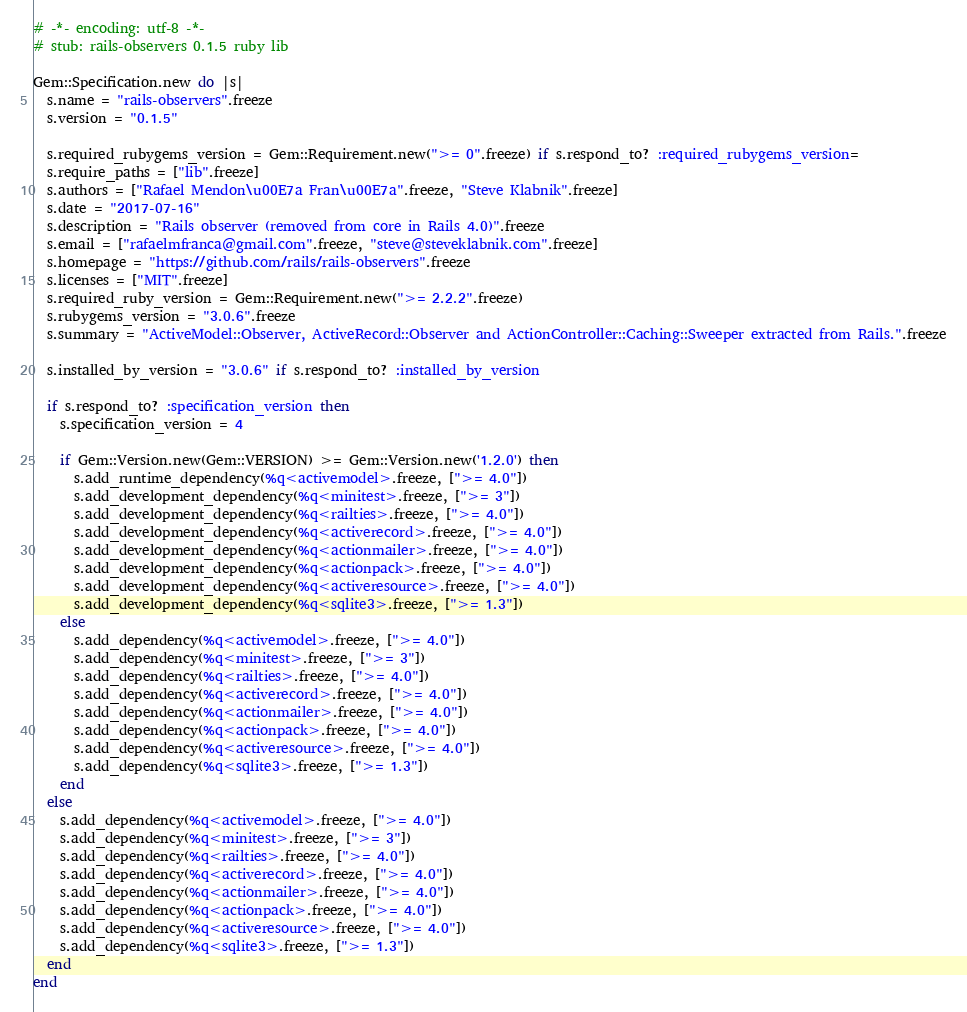<code> <loc_0><loc_0><loc_500><loc_500><_Ruby_># -*- encoding: utf-8 -*-
# stub: rails-observers 0.1.5 ruby lib

Gem::Specification.new do |s|
  s.name = "rails-observers".freeze
  s.version = "0.1.5"

  s.required_rubygems_version = Gem::Requirement.new(">= 0".freeze) if s.respond_to? :required_rubygems_version=
  s.require_paths = ["lib".freeze]
  s.authors = ["Rafael Mendon\u00E7a Fran\u00E7a".freeze, "Steve Klabnik".freeze]
  s.date = "2017-07-16"
  s.description = "Rails observer (removed from core in Rails 4.0)".freeze
  s.email = ["rafaelmfranca@gmail.com".freeze, "steve@steveklabnik.com".freeze]
  s.homepage = "https://github.com/rails/rails-observers".freeze
  s.licenses = ["MIT".freeze]
  s.required_ruby_version = Gem::Requirement.new(">= 2.2.2".freeze)
  s.rubygems_version = "3.0.6".freeze
  s.summary = "ActiveModel::Observer, ActiveRecord::Observer and ActionController::Caching::Sweeper extracted from Rails.".freeze

  s.installed_by_version = "3.0.6" if s.respond_to? :installed_by_version

  if s.respond_to? :specification_version then
    s.specification_version = 4

    if Gem::Version.new(Gem::VERSION) >= Gem::Version.new('1.2.0') then
      s.add_runtime_dependency(%q<activemodel>.freeze, [">= 4.0"])
      s.add_development_dependency(%q<minitest>.freeze, [">= 3"])
      s.add_development_dependency(%q<railties>.freeze, [">= 4.0"])
      s.add_development_dependency(%q<activerecord>.freeze, [">= 4.0"])
      s.add_development_dependency(%q<actionmailer>.freeze, [">= 4.0"])
      s.add_development_dependency(%q<actionpack>.freeze, [">= 4.0"])
      s.add_development_dependency(%q<activeresource>.freeze, [">= 4.0"])
      s.add_development_dependency(%q<sqlite3>.freeze, [">= 1.3"])
    else
      s.add_dependency(%q<activemodel>.freeze, [">= 4.0"])
      s.add_dependency(%q<minitest>.freeze, [">= 3"])
      s.add_dependency(%q<railties>.freeze, [">= 4.0"])
      s.add_dependency(%q<activerecord>.freeze, [">= 4.0"])
      s.add_dependency(%q<actionmailer>.freeze, [">= 4.0"])
      s.add_dependency(%q<actionpack>.freeze, [">= 4.0"])
      s.add_dependency(%q<activeresource>.freeze, [">= 4.0"])
      s.add_dependency(%q<sqlite3>.freeze, [">= 1.3"])
    end
  else
    s.add_dependency(%q<activemodel>.freeze, [">= 4.0"])
    s.add_dependency(%q<minitest>.freeze, [">= 3"])
    s.add_dependency(%q<railties>.freeze, [">= 4.0"])
    s.add_dependency(%q<activerecord>.freeze, [">= 4.0"])
    s.add_dependency(%q<actionmailer>.freeze, [">= 4.0"])
    s.add_dependency(%q<actionpack>.freeze, [">= 4.0"])
    s.add_dependency(%q<activeresource>.freeze, [">= 4.0"])
    s.add_dependency(%q<sqlite3>.freeze, [">= 1.3"])
  end
end
</code> 